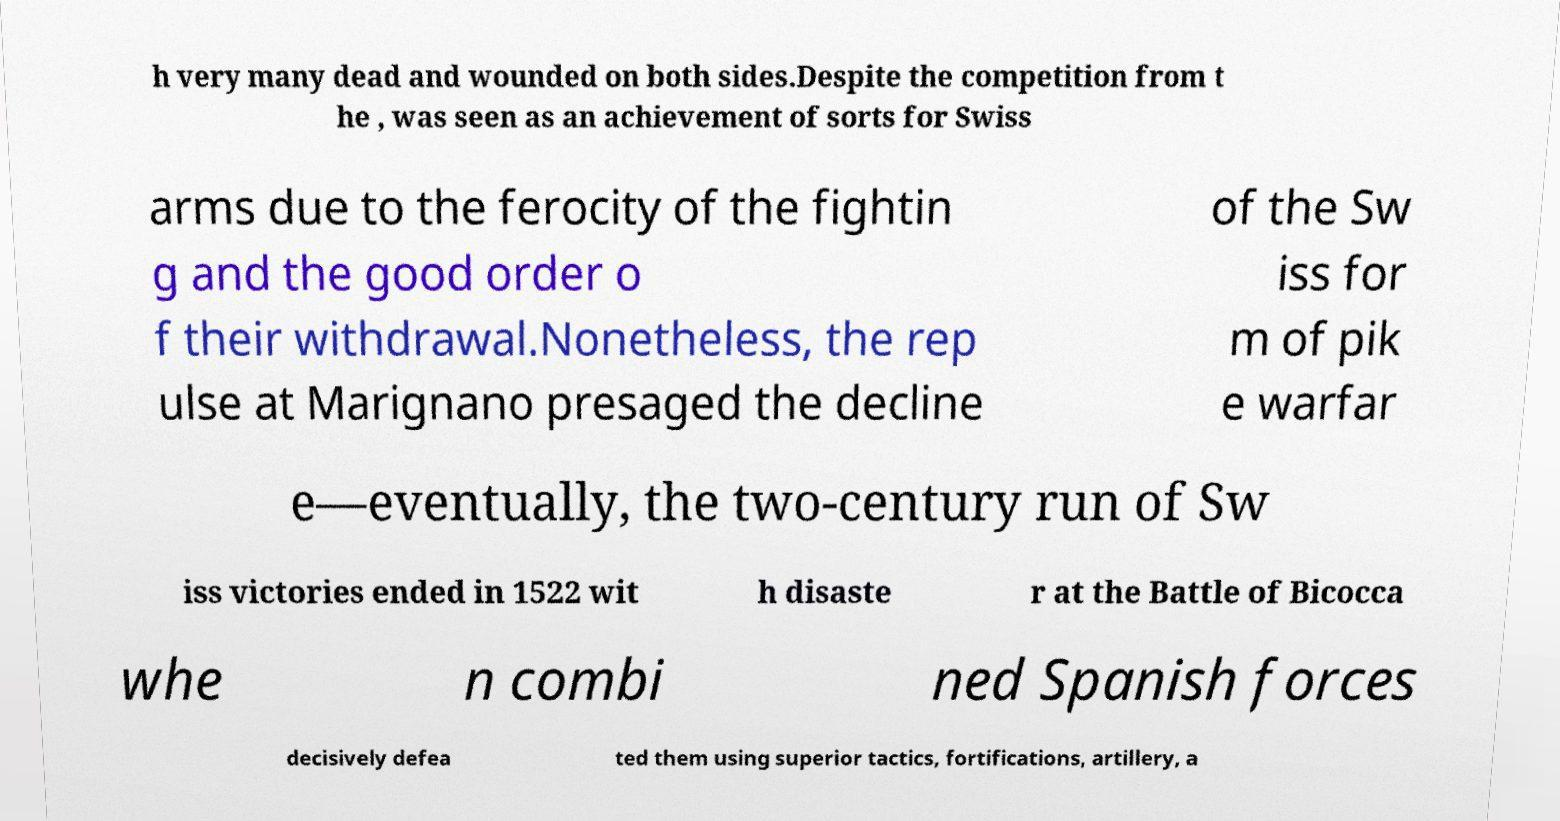Could you assist in decoding the text presented in this image and type it out clearly? h very many dead and wounded on both sides.Despite the competition from t he , was seen as an achievement of sorts for Swiss arms due to the ferocity of the fightin g and the good order o f their withdrawal.Nonetheless, the rep ulse at Marignano presaged the decline of the Sw iss for m of pik e warfar e—eventually, the two-century run of Sw iss victories ended in 1522 wit h disaste r at the Battle of Bicocca whe n combi ned Spanish forces decisively defea ted them using superior tactics, fortifications, artillery, a 